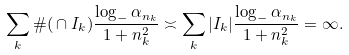<formula> <loc_0><loc_0><loc_500><loc_500>\sum _ { k } \# ( \L \cap I _ { k } ) \frac { \log _ { - } \alpha _ { n _ { k } } } { 1 + n _ { k } ^ { 2 } } \asymp \sum _ { k } | I _ { k } | \frac { \log _ { - } \alpha _ { n _ { k } } } { 1 + n _ { k } ^ { 2 } } = \infty .</formula> 